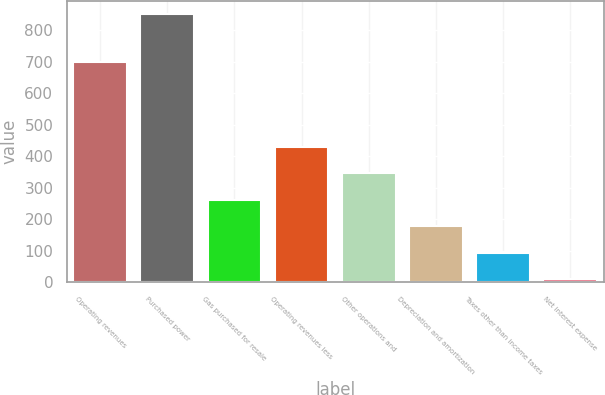<chart> <loc_0><loc_0><loc_500><loc_500><bar_chart><fcel>Operating revenues<fcel>Purchased power<fcel>Gas purchased for resale<fcel>Operating revenues less<fcel>Other operations and<fcel>Depreciation and amortization<fcel>Taxes other than income taxes<fcel>Net interest expense<nl><fcel>698<fcel>851<fcel>262.3<fcel>430.5<fcel>346.4<fcel>178.2<fcel>94.1<fcel>10<nl></chart> 